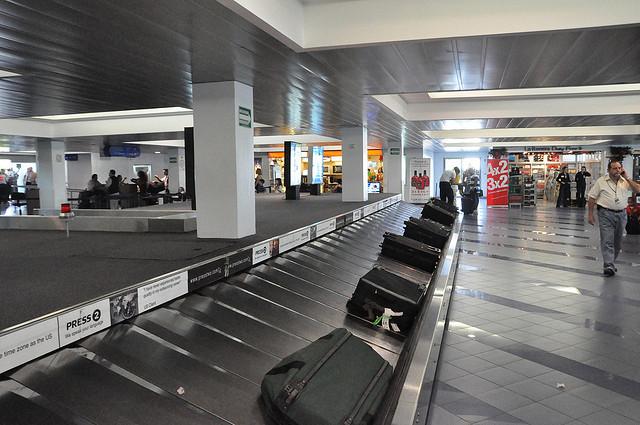How many suitcases are on the belt?
Give a very brief answer. 5. Where was this picture taken?
Answer briefly. Airport. What is the man on the right doing while walking?
Quick response, please. Talking on phone. 